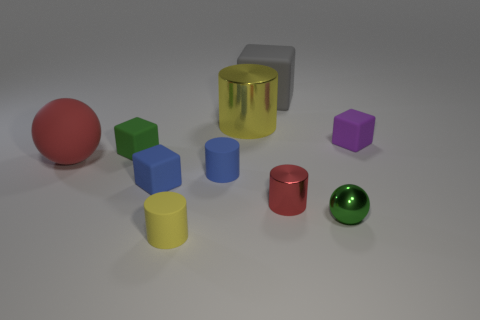Subtract 1 cylinders. How many cylinders are left? 3 Subtract all cubes. How many objects are left? 6 Add 6 tiny blue objects. How many tiny blue objects exist? 8 Subtract 1 yellow cylinders. How many objects are left? 9 Subtract all red shiny cylinders. Subtract all green matte things. How many objects are left? 8 Add 7 small yellow objects. How many small yellow objects are left? 8 